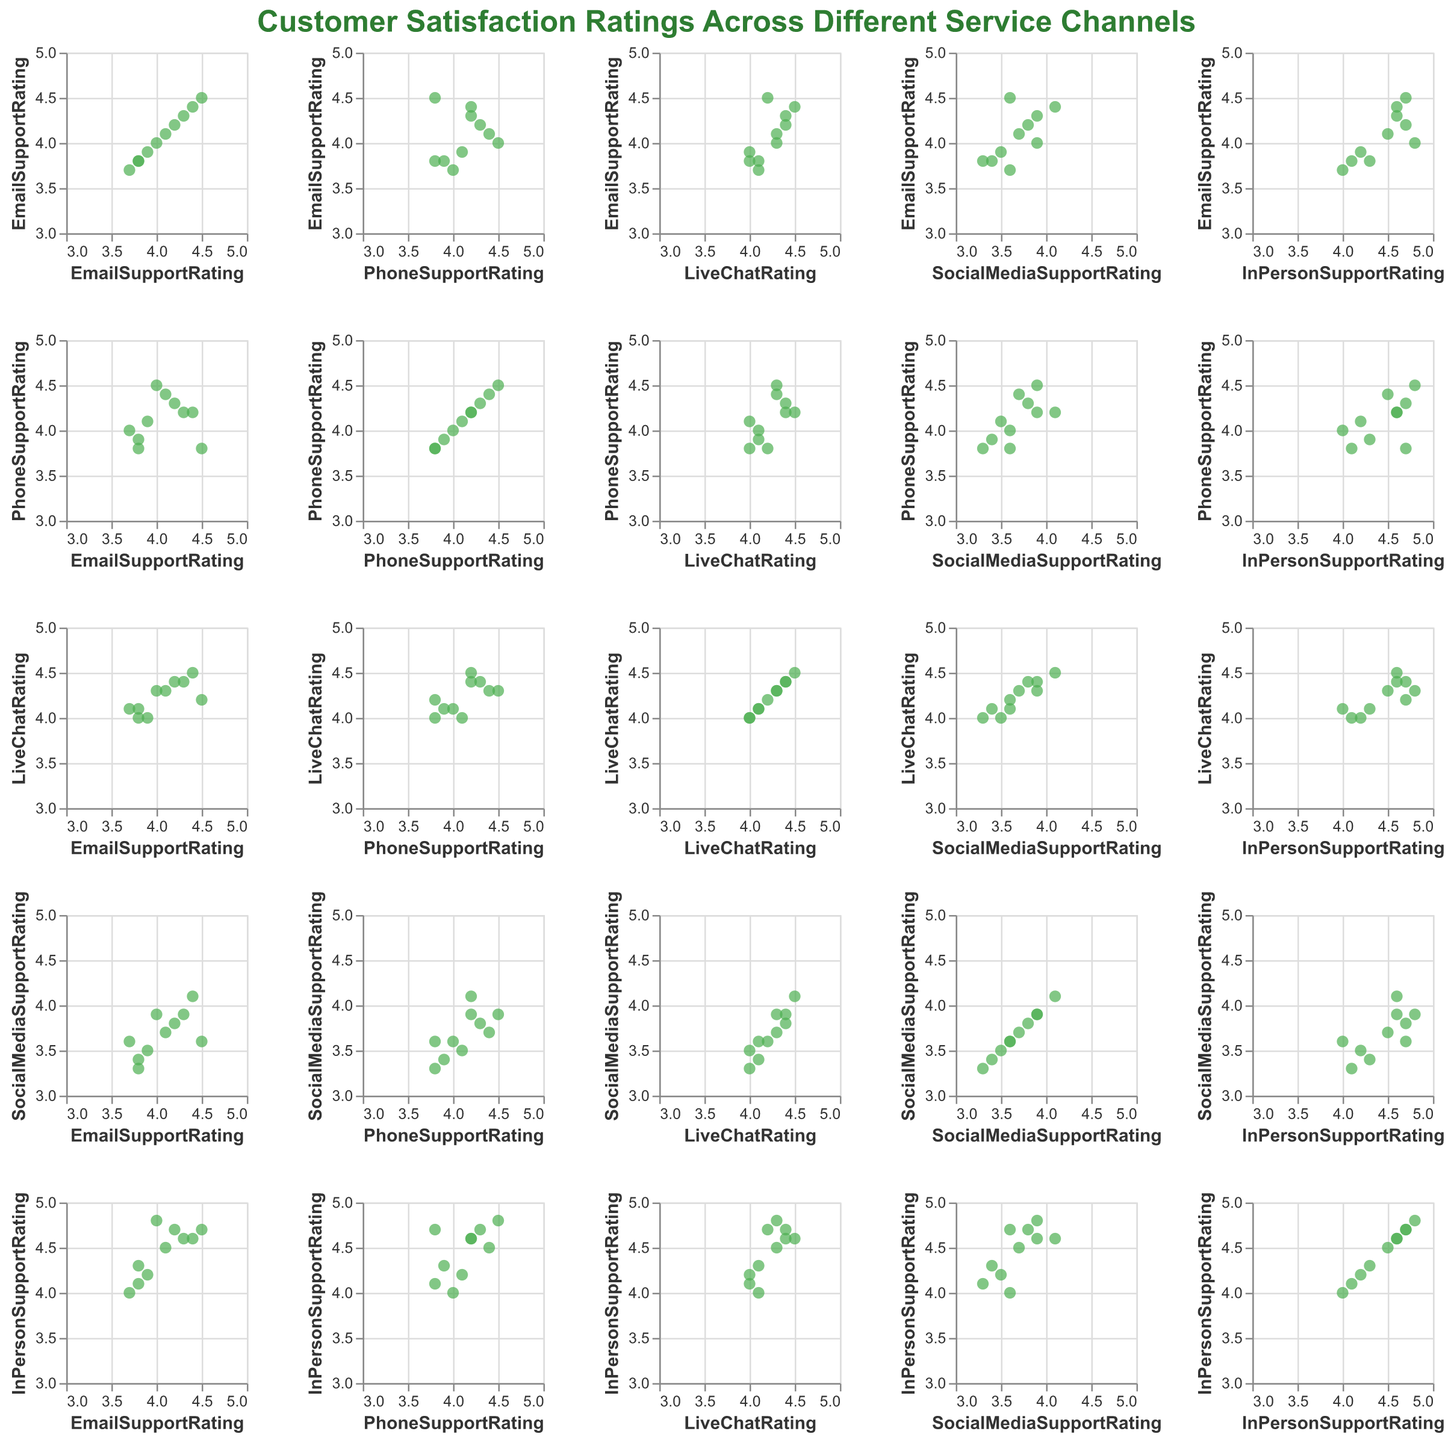What is the title of the figure? The title of the figure is generally located at the top of the visual and is usually larger and bolder compared to other text. It summarizes what the figure is about.
Answer: Customer Satisfaction Ratings Across Different Service Channels What are the axes representing in this scatter plot matrix? The scatter plot matrix usually has both the x-axis and y-axis representing the same set of variables, which can be seen from the repetition of variable names along both axes.
Answer: The axes represent different service channels' satisfaction ratings: Email Support Rating, Phone Support Rating, Live Chat Rating, Social Media Support Rating, In Person Support Rating Which service channel has the highest overall satisfaction rating? By looking at the scatter plots and seeing which service channel has the highest data points consistently across the matrix, we can infer the highest overall rating.
Answer: InPersonSupportRating How do the Email Support Rating and Phone Support Rating correlate? By examining the scatter plot where Email Support Rating is on one axis and Phone Support Rating is on the other, you can observe the pattern of points to determine if there’s a potential correlation.
Answer: There is a moderate positive correlation Which service channels show the least correlation in their ratings? By comparing all the scatter plots in the matrix, you can identify the plots where the data points are most dispersed, indicating a weaker or no correlation.
Answer: SocialMediaSupportRating and InPersonSupportRating What is the range of satisfaction ratings given for the Live Chat Rating? By looking at the plot's axes dedicated to Live Chat Rating, note the minimum and maximum values on the axis to determine the range.
Answer: 4.0 to 4.5 Are there any ratings that appear extreme or unusual in the data? By observing the scatter plots, look for any data points that significantly deviate from the rest of the points. These outliers can indicate extreme ratings.
Answer: No, there appear to be no extreme ratings How many data points are displayed in each scatter plot of the matrix? By counting the number of points in each scatter plot, you can verify consistency in the data representation. Each subplot should have the same number of points if they represent the same set of customers.
Answer: 10 Which two channels have the most similar pattern in their ratings? Comparing the scatter plots, identify which pairs of service channels have data points clustered similarly, indicating similar rating patterns between those channels.
Answer: EmailSupportRating and PhoneSupportRating Does the data suggest any service channel that might need improvement based on lower satisfaction ratings? By looking at the scatter plots and identifying which service channel has consistently lower data points compared to others, you can infer which one might need improvement.
Answer: SocialMediaSupportRating 